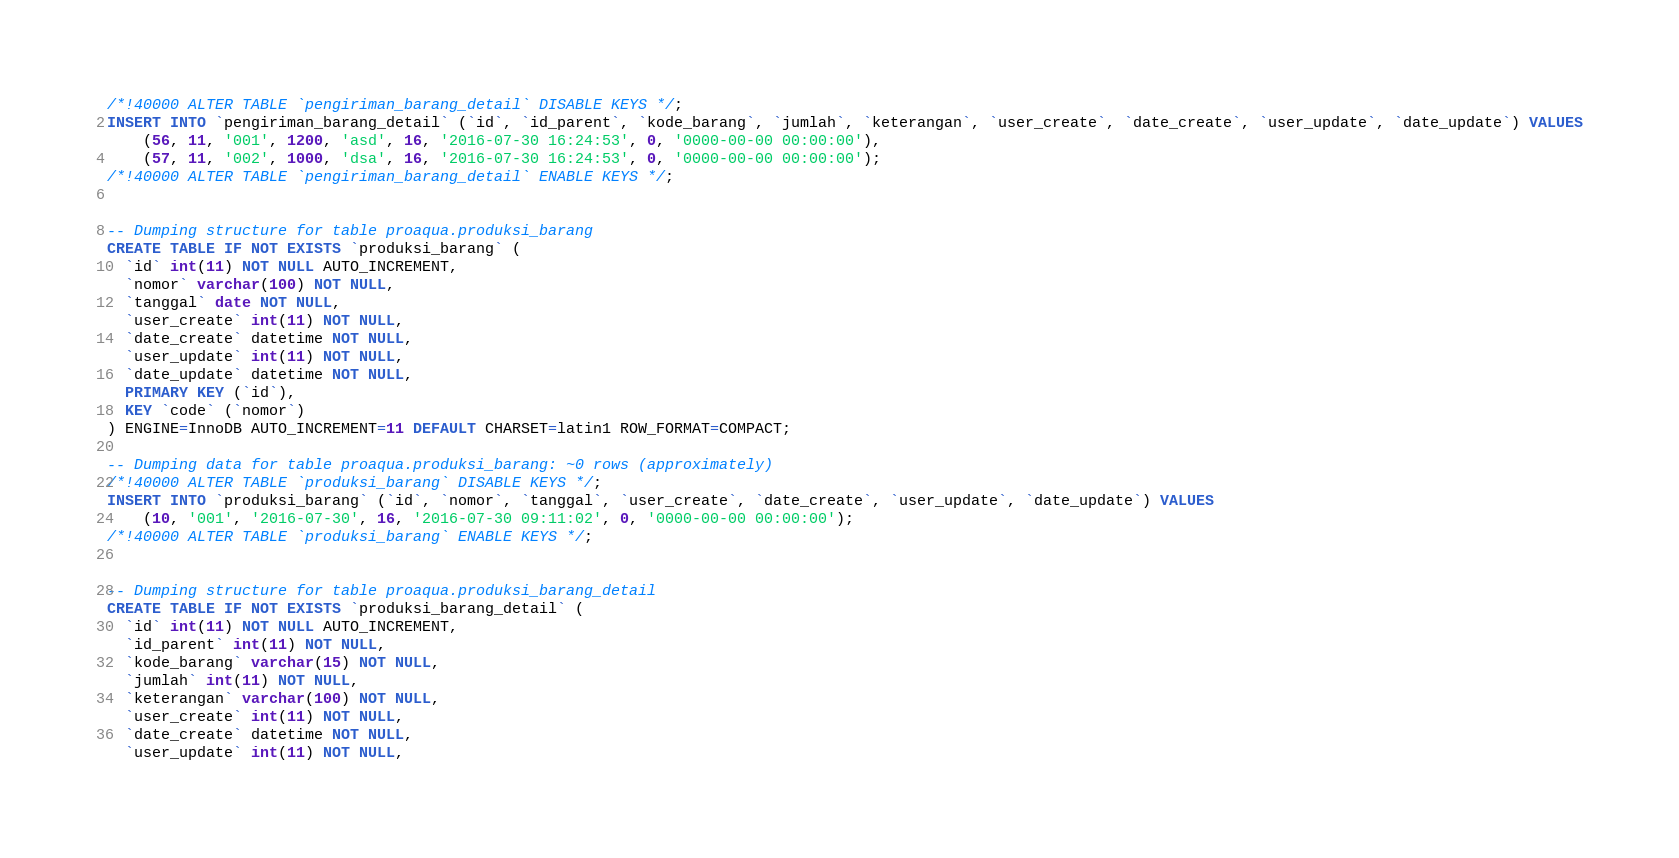Convert code to text. <code><loc_0><loc_0><loc_500><loc_500><_SQL_>/*!40000 ALTER TABLE `pengiriman_barang_detail` DISABLE KEYS */;
INSERT INTO `pengiriman_barang_detail` (`id`, `id_parent`, `kode_barang`, `jumlah`, `keterangan`, `user_create`, `date_create`, `user_update`, `date_update`) VALUES
	(56, 11, '001', 1200, 'asd', 16, '2016-07-30 16:24:53', 0, '0000-00-00 00:00:00'),
	(57, 11, '002', 1000, 'dsa', 16, '2016-07-30 16:24:53', 0, '0000-00-00 00:00:00');
/*!40000 ALTER TABLE `pengiriman_barang_detail` ENABLE KEYS */;


-- Dumping structure for table proaqua.produksi_barang
CREATE TABLE IF NOT EXISTS `produksi_barang` (
  `id` int(11) NOT NULL AUTO_INCREMENT,
  `nomor` varchar(100) NOT NULL,
  `tanggal` date NOT NULL,
  `user_create` int(11) NOT NULL,
  `date_create` datetime NOT NULL,
  `user_update` int(11) NOT NULL,
  `date_update` datetime NOT NULL,
  PRIMARY KEY (`id`),
  KEY `code` (`nomor`)
) ENGINE=InnoDB AUTO_INCREMENT=11 DEFAULT CHARSET=latin1 ROW_FORMAT=COMPACT;

-- Dumping data for table proaqua.produksi_barang: ~0 rows (approximately)
/*!40000 ALTER TABLE `produksi_barang` DISABLE KEYS */;
INSERT INTO `produksi_barang` (`id`, `nomor`, `tanggal`, `user_create`, `date_create`, `user_update`, `date_update`) VALUES
	(10, '001', '2016-07-30', 16, '2016-07-30 09:11:02', 0, '0000-00-00 00:00:00');
/*!40000 ALTER TABLE `produksi_barang` ENABLE KEYS */;


-- Dumping structure for table proaqua.produksi_barang_detail
CREATE TABLE IF NOT EXISTS `produksi_barang_detail` (
  `id` int(11) NOT NULL AUTO_INCREMENT,
  `id_parent` int(11) NOT NULL,
  `kode_barang` varchar(15) NOT NULL,
  `jumlah` int(11) NOT NULL,
  `keterangan` varchar(100) NOT NULL,
  `user_create` int(11) NOT NULL,
  `date_create` datetime NOT NULL,
  `user_update` int(11) NOT NULL,</code> 